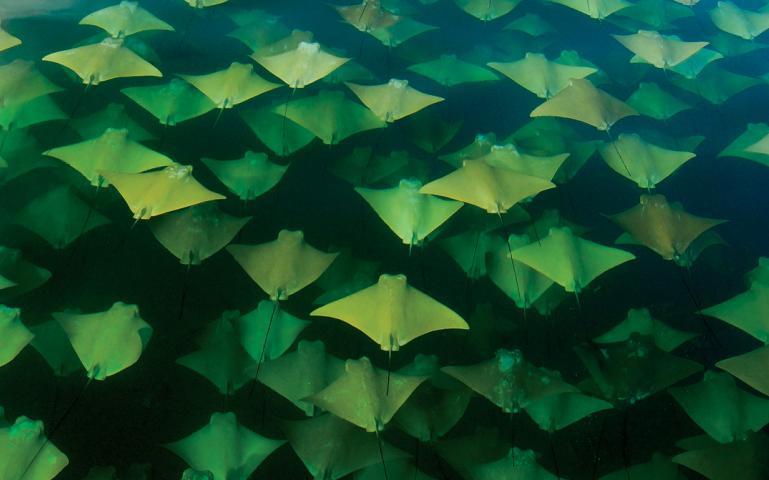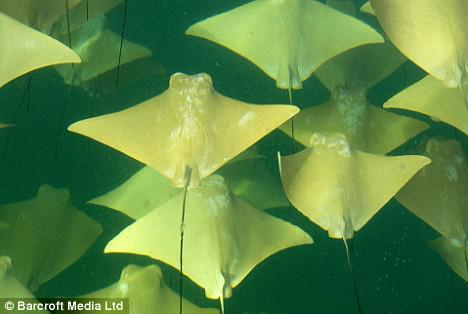The first image is the image on the left, the second image is the image on the right. Considering the images on both sides, is "An image shows a mass of stingrays in vivid blue water." valid? Answer yes or no. No. The first image is the image on the left, the second image is the image on the right. Analyze the images presented: Is the assertion "Animals are in blue water in the image on the right." valid? Answer yes or no. No. 